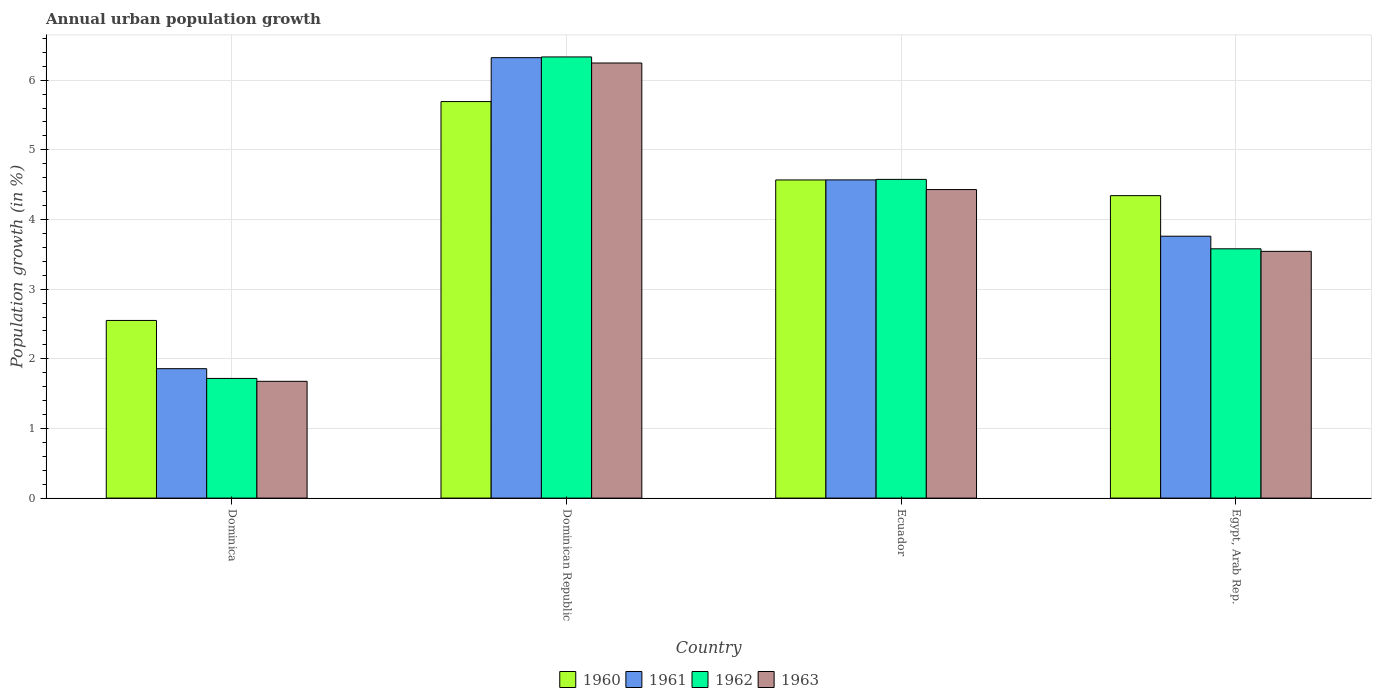How many different coloured bars are there?
Keep it short and to the point. 4. How many groups of bars are there?
Provide a succinct answer. 4. Are the number of bars per tick equal to the number of legend labels?
Ensure brevity in your answer.  Yes. How many bars are there on the 1st tick from the left?
Your response must be concise. 4. How many bars are there on the 3rd tick from the right?
Offer a very short reply. 4. What is the label of the 3rd group of bars from the left?
Your answer should be very brief. Ecuador. What is the percentage of urban population growth in 1962 in Dominica?
Provide a succinct answer. 1.72. Across all countries, what is the maximum percentage of urban population growth in 1962?
Provide a short and direct response. 6.33. Across all countries, what is the minimum percentage of urban population growth in 1963?
Give a very brief answer. 1.68. In which country was the percentage of urban population growth in 1961 maximum?
Your answer should be very brief. Dominican Republic. In which country was the percentage of urban population growth in 1961 minimum?
Your answer should be compact. Dominica. What is the total percentage of urban population growth in 1960 in the graph?
Offer a very short reply. 17.15. What is the difference between the percentage of urban population growth in 1962 in Dominica and that in Dominican Republic?
Ensure brevity in your answer.  -4.62. What is the difference between the percentage of urban population growth in 1962 in Egypt, Arab Rep. and the percentage of urban population growth in 1963 in Dominica?
Offer a very short reply. 1.9. What is the average percentage of urban population growth in 1960 per country?
Your response must be concise. 4.29. What is the difference between the percentage of urban population growth of/in 1960 and percentage of urban population growth of/in 1963 in Dominican Republic?
Offer a very short reply. -0.55. What is the ratio of the percentage of urban population growth in 1963 in Dominica to that in Ecuador?
Provide a short and direct response. 0.38. Is the difference between the percentage of urban population growth in 1960 in Dominican Republic and Ecuador greater than the difference between the percentage of urban population growth in 1963 in Dominican Republic and Ecuador?
Keep it short and to the point. No. What is the difference between the highest and the second highest percentage of urban population growth in 1960?
Make the answer very short. -0.23. What is the difference between the highest and the lowest percentage of urban population growth in 1961?
Provide a short and direct response. 4.47. How many bars are there?
Your answer should be very brief. 16. Are all the bars in the graph horizontal?
Your answer should be very brief. No. Are the values on the major ticks of Y-axis written in scientific E-notation?
Your response must be concise. No. Does the graph contain any zero values?
Your response must be concise. No. Does the graph contain grids?
Make the answer very short. Yes. Where does the legend appear in the graph?
Your answer should be compact. Bottom center. What is the title of the graph?
Make the answer very short. Annual urban population growth. What is the label or title of the Y-axis?
Provide a short and direct response. Population growth (in %). What is the Population growth (in %) in 1960 in Dominica?
Your answer should be very brief. 2.55. What is the Population growth (in %) in 1961 in Dominica?
Your response must be concise. 1.86. What is the Population growth (in %) of 1962 in Dominica?
Provide a short and direct response. 1.72. What is the Population growth (in %) in 1963 in Dominica?
Keep it short and to the point. 1.68. What is the Population growth (in %) of 1960 in Dominican Republic?
Give a very brief answer. 5.69. What is the Population growth (in %) of 1961 in Dominican Republic?
Ensure brevity in your answer.  6.32. What is the Population growth (in %) in 1962 in Dominican Republic?
Offer a terse response. 6.33. What is the Population growth (in %) in 1963 in Dominican Republic?
Provide a succinct answer. 6.25. What is the Population growth (in %) of 1960 in Ecuador?
Offer a terse response. 4.57. What is the Population growth (in %) of 1961 in Ecuador?
Offer a terse response. 4.57. What is the Population growth (in %) in 1962 in Ecuador?
Provide a short and direct response. 4.58. What is the Population growth (in %) in 1963 in Ecuador?
Provide a short and direct response. 4.43. What is the Population growth (in %) of 1960 in Egypt, Arab Rep.?
Ensure brevity in your answer.  4.34. What is the Population growth (in %) in 1961 in Egypt, Arab Rep.?
Offer a very short reply. 3.76. What is the Population growth (in %) of 1962 in Egypt, Arab Rep.?
Keep it short and to the point. 3.58. What is the Population growth (in %) of 1963 in Egypt, Arab Rep.?
Offer a terse response. 3.54. Across all countries, what is the maximum Population growth (in %) in 1960?
Offer a very short reply. 5.69. Across all countries, what is the maximum Population growth (in %) of 1961?
Provide a short and direct response. 6.32. Across all countries, what is the maximum Population growth (in %) of 1962?
Ensure brevity in your answer.  6.33. Across all countries, what is the maximum Population growth (in %) of 1963?
Give a very brief answer. 6.25. Across all countries, what is the minimum Population growth (in %) of 1960?
Give a very brief answer. 2.55. Across all countries, what is the minimum Population growth (in %) of 1961?
Give a very brief answer. 1.86. Across all countries, what is the minimum Population growth (in %) in 1962?
Offer a terse response. 1.72. Across all countries, what is the minimum Population growth (in %) in 1963?
Your response must be concise. 1.68. What is the total Population growth (in %) in 1960 in the graph?
Provide a succinct answer. 17.15. What is the total Population growth (in %) of 1961 in the graph?
Ensure brevity in your answer.  16.51. What is the total Population growth (in %) in 1962 in the graph?
Offer a very short reply. 16.21. What is the total Population growth (in %) of 1963 in the graph?
Ensure brevity in your answer.  15.9. What is the difference between the Population growth (in %) of 1960 in Dominica and that in Dominican Republic?
Make the answer very short. -3.14. What is the difference between the Population growth (in %) of 1961 in Dominica and that in Dominican Republic?
Provide a succinct answer. -4.47. What is the difference between the Population growth (in %) of 1962 in Dominica and that in Dominican Republic?
Make the answer very short. -4.62. What is the difference between the Population growth (in %) in 1963 in Dominica and that in Dominican Republic?
Provide a short and direct response. -4.57. What is the difference between the Population growth (in %) in 1960 in Dominica and that in Ecuador?
Give a very brief answer. -2.02. What is the difference between the Population growth (in %) in 1961 in Dominica and that in Ecuador?
Ensure brevity in your answer.  -2.71. What is the difference between the Population growth (in %) of 1962 in Dominica and that in Ecuador?
Keep it short and to the point. -2.86. What is the difference between the Population growth (in %) in 1963 in Dominica and that in Ecuador?
Ensure brevity in your answer.  -2.75. What is the difference between the Population growth (in %) of 1960 in Dominica and that in Egypt, Arab Rep.?
Your answer should be very brief. -1.79. What is the difference between the Population growth (in %) of 1961 in Dominica and that in Egypt, Arab Rep.?
Ensure brevity in your answer.  -1.9. What is the difference between the Population growth (in %) in 1962 in Dominica and that in Egypt, Arab Rep.?
Make the answer very short. -1.86. What is the difference between the Population growth (in %) in 1963 in Dominica and that in Egypt, Arab Rep.?
Ensure brevity in your answer.  -1.87. What is the difference between the Population growth (in %) in 1960 in Dominican Republic and that in Ecuador?
Your response must be concise. 1.13. What is the difference between the Population growth (in %) in 1961 in Dominican Republic and that in Ecuador?
Make the answer very short. 1.75. What is the difference between the Population growth (in %) of 1962 in Dominican Republic and that in Ecuador?
Provide a succinct answer. 1.76. What is the difference between the Population growth (in %) in 1963 in Dominican Republic and that in Ecuador?
Keep it short and to the point. 1.82. What is the difference between the Population growth (in %) in 1960 in Dominican Republic and that in Egypt, Arab Rep.?
Your answer should be compact. 1.35. What is the difference between the Population growth (in %) of 1961 in Dominican Republic and that in Egypt, Arab Rep.?
Provide a short and direct response. 2.56. What is the difference between the Population growth (in %) of 1962 in Dominican Republic and that in Egypt, Arab Rep.?
Your response must be concise. 2.75. What is the difference between the Population growth (in %) of 1963 in Dominican Republic and that in Egypt, Arab Rep.?
Keep it short and to the point. 2.7. What is the difference between the Population growth (in %) of 1960 in Ecuador and that in Egypt, Arab Rep.?
Make the answer very short. 0.23. What is the difference between the Population growth (in %) in 1961 in Ecuador and that in Egypt, Arab Rep.?
Make the answer very short. 0.81. What is the difference between the Population growth (in %) of 1963 in Ecuador and that in Egypt, Arab Rep.?
Provide a short and direct response. 0.89. What is the difference between the Population growth (in %) of 1960 in Dominica and the Population growth (in %) of 1961 in Dominican Republic?
Your answer should be very brief. -3.77. What is the difference between the Population growth (in %) in 1960 in Dominica and the Population growth (in %) in 1962 in Dominican Republic?
Offer a terse response. -3.78. What is the difference between the Population growth (in %) in 1960 in Dominica and the Population growth (in %) in 1963 in Dominican Republic?
Your response must be concise. -3.7. What is the difference between the Population growth (in %) of 1961 in Dominica and the Population growth (in %) of 1962 in Dominican Republic?
Keep it short and to the point. -4.48. What is the difference between the Population growth (in %) in 1961 in Dominica and the Population growth (in %) in 1963 in Dominican Republic?
Offer a terse response. -4.39. What is the difference between the Population growth (in %) in 1962 in Dominica and the Population growth (in %) in 1963 in Dominican Republic?
Offer a terse response. -4.53. What is the difference between the Population growth (in %) in 1960 in Dominica and the Population growth (in %) in 1961 in Ecuador?
Offer a terse response. -2.02. What is the difference between the Population growth (in %) in 1960 in Dominica and the Population growth (in %) in 1962 in Ecuador?
Ensure brevity in your answer.  -2.03. What is the difference between the Population growth (in %) in 1960 in Dominica and the Population growth (in %) in 1963 in Ecuador?
Your answer should be very brief. -1.88. What is the difference between the Population growth (in %) in 1961 in Dominica and the Population growth (in %) in 1962 in Ecuador?
Give a very brief answer. -2.72. What is the difference between the Population growth (in %) of 1961 in Dominica and the Population growth (in %) of 1963 in Ecuador?
Your answer should be compact. -2.57. What is the difference between the Population growth (in %) of 1962 in Dominica and the Population growth (in %) of 1963 in Ecuador?
Provide a succinct answer. -2.71. What is the difference between the Population growth (in %) of 1960 in Dominica and the Population growth (in %) of 1961 in Egypt, Arab Rep.?
Make the answer very short. -1.21. What is the difference between the Population growth (in %) in 1960 in Dominica and the Population growth (in %) in 1962 in Egypt, Arab Rep.?
Offer a terse response. -1.03. What is the difference between the Population growth (in %) of 1960 in Dominica and the Population growth (in %) of 1963 in Egypt, Arab Rep.?
Provide a succinct answer. -0.99. What is the difference between the Population growth (in %) in 1961 in Dominica and the Population growth (in %) in 1962 in Egypt, Arab Rep.?
Make the answer very short. -1.72. What is the difference between the Population growth (in %) in 1961 in Dominica and the Population growth (in %) in 1963 in Egypt, Arab Rep.?
Keep it short and to the point. -1.68. What is the difference between the Population growth (in %) of 1962 in Dominica and the Population growth (in %) of 1963 in Egypt, Arab Rep.?
Ensure brevity in your answer.  -1.82. What is the difference between the Population growth (in %) in 1960 in Dominican Republic and the Population growth (in %) in 1961 in Ecuador?
Keep it short and to the point. 1.12. What is the difference between the Population growth (in %) of 1960 in Dominican Republic and the Population growth (in %) of 1962 in Ecuador?
Your answer should be compact. 1.12. What is the difference between the Population growth (in %) of 1960 in Dominican Republic and the Population growth (in %) of 1963 in Ecuador?
Your answer should be very brief. 1.26. What is the difference between the Population growth (in %) of 1961 in Dominican Republic and the Population growth (in %) of 1962 in Ecuador?
Your answer should be compact. 1.75. What is the difference between the Population growth (in %) in 1961 in Dominican Republic and the Population growth (in %) in 1963 in Ecuador?
Make the answer very short. 1.89. What is the difference between the Population growth (in %) of 1962 in Dominican Republic and the Population growth (in %) of 1963 in Ecuador?
Your response must be concise. 1.9. What is the difference between the Population growth (in %) in 1960 in Dominican Republic and the Population growth (in %) in 1961 in Egypt, Arab Rep.?
Ensure brevity in your answer.  1.93. What is the difference between the Population growth (in %) of 1960 in Dominican Republic and the Population growth (in %) of 1962 in Egypt, Arab Rep.?
Offer a terse response. 2.11. What is the difference between the Population growth (in %) of 1960 in Dominican Republic and the Population growth (in %) of 1963 in Egypt, Arab Rep.?
Offer a terse response. 2.15. What is the difference between the Population growth (in %) in 1961 in Dominican Republic and the Population growth (in %) in 1962 in Egypt, Arab Rep.?
Provide a succinct answer. 2.74. What is the difference between the Population growth (in %) of 1961 in Dominican Republic and the Population growth (in %) of 1963 in Egypt, Arab Rep.?
Provide a succinct answer. 2.78. What is the difference between the Population growth (in %) of 1962 in Dominican Republic and the Population growth (in %) of 1963 in Egypt, Arab Rep.?
Offer a terse response. 2.79. What is the difference between the Population growth (in %) of 1960 in Ecuador and the Population growth (in %) of 1961 in Egypt, Arab Rep.?
Offer a very short reply. 0.81. What is the difference between the Population growth (in %) in 1960 in Ecuador and the Population growth (in %) in 1963 in Egypt, Arab Rep.?
Provide a short and direct response. 1.03. What is the difference between the Population growth (in %) in 1961 in Ecuador and the Population growth (in %) in 1962 in Egypt, Arab Rep.?
Your response must be concise. 0.99. What is the difference between the Population growth (in %) in 1961 in Ecuador and the Population growth (in %) in 1963 in Egypt, Arab Rep.?
Make the answer very short. 1.03. What is the difference between the Population growth (in %) in 1962 in Ecuador and the Population growth (in %) in 1963 in Egypt, Arab Rep.?
Make the answer very short. 1.03. What is the average Population growth (in %) of 1960 per country?
Keep it short and to the point. 4.29. What is the average Population growth (in %) of 1961 per country?
Keep it short and to the point. 4.13. What is the average Population growth (in %) in 1962 per country?
Your answer should be compact. 4.05. What is the average Population growth (in %) in 1963 per country?
Provide a short and direct response. 3.97. What is the difference between the Population growth (in %) of 1960 and Population growth (in %) of 1961 in Dominica?
Provide a succinct answer. 0.69. What is the difference between the Population growth (in %) in 1960 and Population growth (in %) in 1962 in Dominica?
Provide a succinct answer. 0.83. What is the difference between the Population growth (in %) of 1960 and Population growth (in %) of 1963 in Dominica?
Keep it short and to the point. 0.87. What is the difference between the Population growth (in %) in 1961 and Population growth (in %) in 1962 in Dominica?
Ensure brevity in your answer.  0.14. What is the difference between the Population growth (in %) in 1961 and Population growth (in %) in 1963 in Dominica?
Give a very brief answer. 0.18. What is the difference between the Population growth (in %) in 1962 and Population growth (in %) in 1963 in Dominica?
Your response must be concise. 0.04. What is the difference between the Population growth (in %) of 1960 and Population growth (in %) of 1961 in Dominican Republic?
Make the answer very short. -0.63. What is the difference between the Population growth (in %) in 1960 and Population growth (in %) in 1962 in Dominican Republic?
Your response must be concise. -0.64. What is the difference between the Population growth (in %) in 1960 and Population growth (in %) in 1963 in Dominican Republic?
Your answer should be compact. -0.55. What is the difference between the Population growth (in %) in 1961 and Population growth (in %) in 1962 in Dominican Republic?
Your response must be concise. -0.01. What is the difference between the Population growth (in %) of 1961 and Population growth (in %) of 1963 in Dominican Republic?
Provide a short and direct response. 0.08. What is the difference between the Population growth (in %) in 1962 and Population growth (in %) in 1963 in Dominican Republic?
Make the answer very short. 0.09. What is the difference between the Population growth (in %) in 1960 and Population growth (in %) in 1961 in Ecuador?
Ensure brevity in your answer.  -0. What is the difference between the Population growth (in %) of 1960 and Population growth (in %) of 1962 in Ecuador?
Make the answer very short. -0.01. What is the difference between the Population growth (in %) in 1960 and Population growth (in %) in 1963 in Ecuador?
Keep it short and to the point. 0.14. What is the difference between the Population growth (in %) of 1961 and Population growth (in %) of 1962 in Ecuador?
Your response must be concise. -0.01. What is the difference between the Population growth (in %) in 1961 and Population growth (in %) in 1963 in Ecuador?
Provide a short and direct response. 0.14. What is the difference between the Population growth (in %) of 1962 and Population growth (in %) of 1963 in Ecuador?
Ensure brevity in your answer.  0.15. What is the difference between the Population growth (in %) in 1960 and Population growth (in %) in 1961 in Egypt, Arab Rep.?
Your answer should be compact. 0.58. What is the difference between the Population growth (in %) of 1960 and Population growth (in %) of 1962 in Egypt, Arab Rep.?
Your response must be concise. 0.76. What is the difference between the Population growth (in %) in 1960 and Population growth (in %) in 1963 in Egypt, Arab Rep.?
Make the answer very short. 0.8. What is the difference between the Population growth (in %) of 1961 and Population growth (in %) of 1962 in Egypt, Arab Rep.?
Offer a very short reply. 0.18. What is the difference between the Population growth (in %) in 1961 and Population growth (in %) in 1963 in Egypt, Arab Rep.?
Ensure brevity in your answer.  0.22. What is the difference between the Population growth (in %) of 1962 and Population growth (in %) of 1963 in Egypt, Arab Rep.?
Offer a very short reply. 0.04. What is the ratio of the Population growth (in %) in 1960 in Dominica to that in Dominican Republic?
Ensure brevity in your answer.  0.45. What is the ratio of the Population growth (in %) in 1961 in Dominica to that in Dominican Republic?
Your answer should be very brief. 0.29. What is the ratio of the Population growth (in %) in 1962 in Dominica to that in Dominican Republic?
Your answer should be compact. 0.27. What is the ratio of the Population growth (in %) in 1963 in Dominica to that in Dominican Republic?
Your response must be concise. 0.27. What is the ratio of the Population growth (in %) in 1960 in Dominica to that in Ecuador?
Give a very brief answer. 0.56. What is the ratio of the Population growth (in %) in 1961 in Dominica to that in Ecuador?
Make the answer very short. 0.41. What is the ratio of the Population growth (in %) in 1962 in Dominica to that in Ecuador?
Provide a short and direct response. 0.38. What is the ratio of the Population growth (in %) of 1963 in Dominica to that in Ecuador?
Make the answer very short. 0.38. What is the ratio of the Population growth (in %) in 1960 in Dominica to that in Egypt, Arab Rep.?
Provide a short and direct response. 0.59. What is the ratio of the Population growth (in %) of 1961 in Dominica to that in Egypt, Arab Rep.?
Your answer should be compact. 0.49. What is the ratio of the Population growth (in %) in 1962 in Dominica to that in Egypt, Arab Rep.?
Your answer should be very brief. 0.48. What is the ratio of the Population growth (in %) of 1963 in Dominica to that in Egypt, Arab Rep.?
Ensure brevity in your answer.  0.47. What is the ratio of the Population growth (in %) in 1960 in Dominican Republic to that in Ecuador?
Give a very brief answer. 1.25. What is the ratio of the Population growth (in %) of 1961 in Dominican Republic to that in Ecuador?
Offer a very short reply. 1.38. What is the ratio of the Population growth (in %) of 1962 in Dominican Republic to that in Ecuador?
Your response must be concise. 1.38. What is the ratio of the Population growth (in %) of 1963 in Dominican Republic to that in Ecuador?
Offer a terse response. 1.41. What is the ratio of the Population growth (in %) of 1960 in Dominican Republic to that in Egypt, Arab Rep.?
Provide a succinct answer. 1.31. What is the ratio of the Population growth (in %) of 1961 in Dominican Republic to that in Egypt, Arab Rep.?
Make the answer very short. 1.68. What is the ratio of the Population growth (in %) of 1962 in Dominican Republic to that in Egypt, Arab Rep.?
Provide a short and direct response. 1.77. What is the ratio of the Population growth (in %) of 1963 in Dominican Republic to that in Egypt, Arab Rep.?
Your response must be concise. 1.76. What is the ratio of the Population growth (in %) of 1960 in Ecuador to that in Egypt, Arab Rep.?
Offer a terse response. 1.05. What is the ratio of the Population growth (in %) in 1961 in Ecuador to that in Egypt, Arab Rep.?
Make the answer very short. 1.22. What is the ratio of the Population growth (in %) of 1962 in Ecuador to that in Egypt, Arab Rep.?
Keep it short and to the point. 1.28. What is the ratio of the Population growth (in %) of 1963 in Ecuador to that in Egypt, Arab Rep.?
Ensure brevity in your answer.  1.25. What is the difference between the highest and the second highest Population growth (in %) in 1960?
Provide a succinct answer. 1.13. What is the difference between the highest and the second highest Population growth (in %) in 1961?
Your response must be concise. 1.75. What is the difference between the highest and the second highest Population growth (in %) of 1962?
Give a very brief answer. 1.76. What is the difference between the highest and the second highest Population growth (in %) in 1963?
Keep it short and to the point. 1.82. What is the difference between the highest and the lowest Population growth (in %) in 1960?
Provide a short and direct response. 3.14. What is the difference between the highest and the lowest Population growth (in %) in 1961?
Give a very brief answer. 4.47. What is the difference between the highest and the lowest Population growth (in %) of 1962?
Make the answer very short. 4.62. What is the difference between the highest and the lowest Population growth (in %) in 1963?
Give a very brief answer. 4.57. 